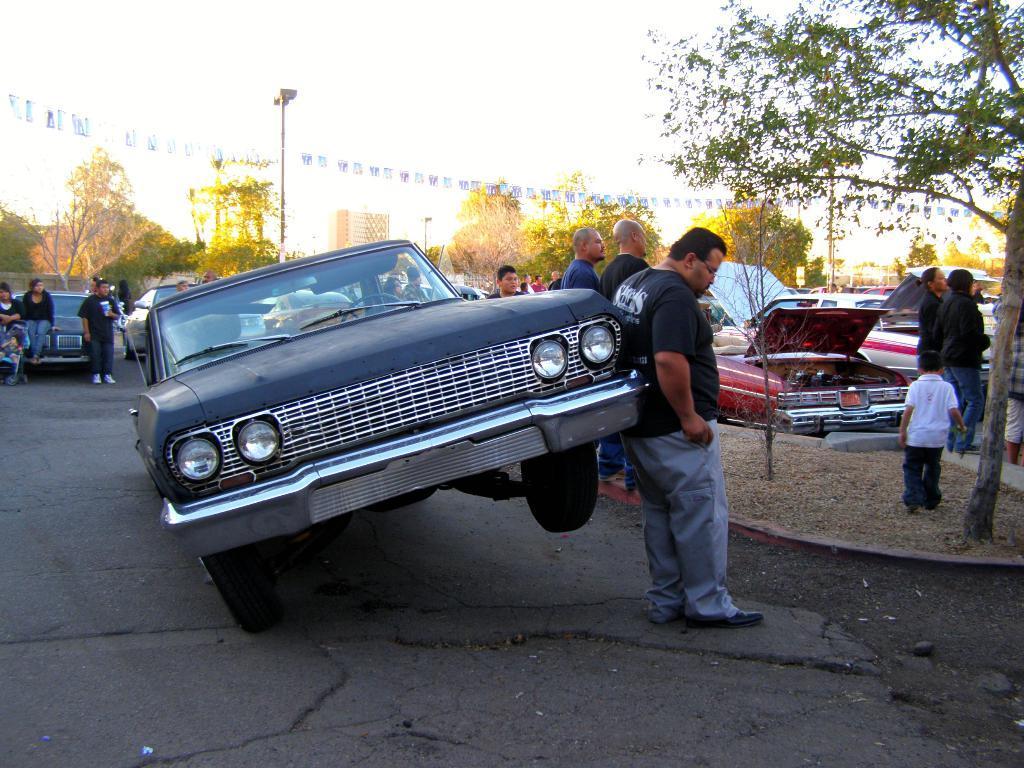Please provide a concise description of this image. There are vehicles and few persons on the road. Here we can see trees, poles, flags, and buildings. In the background there is sky. 